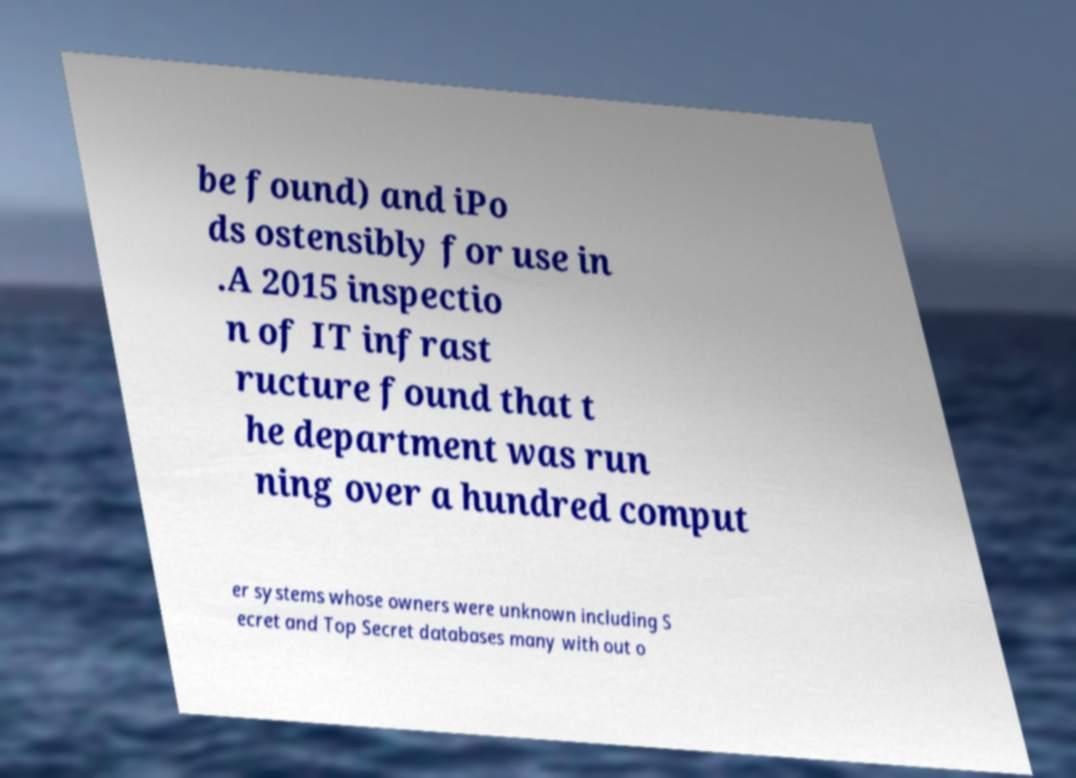For documentation purposes, I need the text within this image transcribed. Could you provide that? be found) and iPo ds ostensibly for use in .A 2015 inspectio n of IT infrast ructure found that t he department was run ning over a hundred comput er systems whose owners were unknown including S ecret and Top Secret databases many with out o 